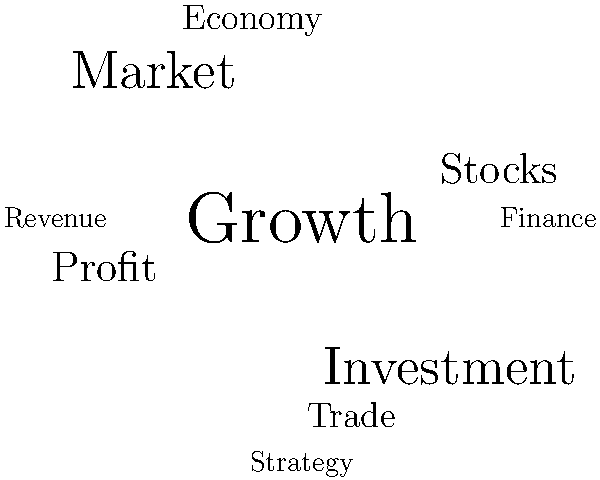Based on the word cloud visualization of common business terms, which word appears to have the most positive sentiment and could be considered the central theme in this business context? To analyze the sentiment and determine the central theme from this word cloud visualization, we need to follow these steps:

1. Observe the size of the words: In word clouds, the size of a word typically represents its frequency or importance.
2. Consider the positioning: Words placed more centrally often carry more weight.
3. Analyze the sentiment: Evaluate the emotional tone of each word in a business context.
4. Compare the words: Determine which word best fits the criteria of positive sentiment and central importance.

Let's analyze the prominent words:

1. "Growth" is the largest and centrally positioned word, indicating its high importance.
2. "Market" and "Investment" are the next largest, but slightly off-center.
3. "Profit," "Stocks," "Economy," and "Trade" are medium-sized and spread around.
4. "Revenue," "Finance," and "Strategy" are smaller and on the edges.

In a business context:
- "Growth" has a very positive connotation, implying progress and success.
- "Market" and "Investment" are neutral to positive, depending on context.
- "Profit" is positive but not as broad or forward-looking as "Growth."
- Other terms like "Stocks," "Economy," and "Trade" are more neutral or situational.

Given its size, central position, and universally positive connotation in business, "Growth" stands out as the word with the most positive sentiment and appears to be the central theme of this word cloud.
Answer: Growth 